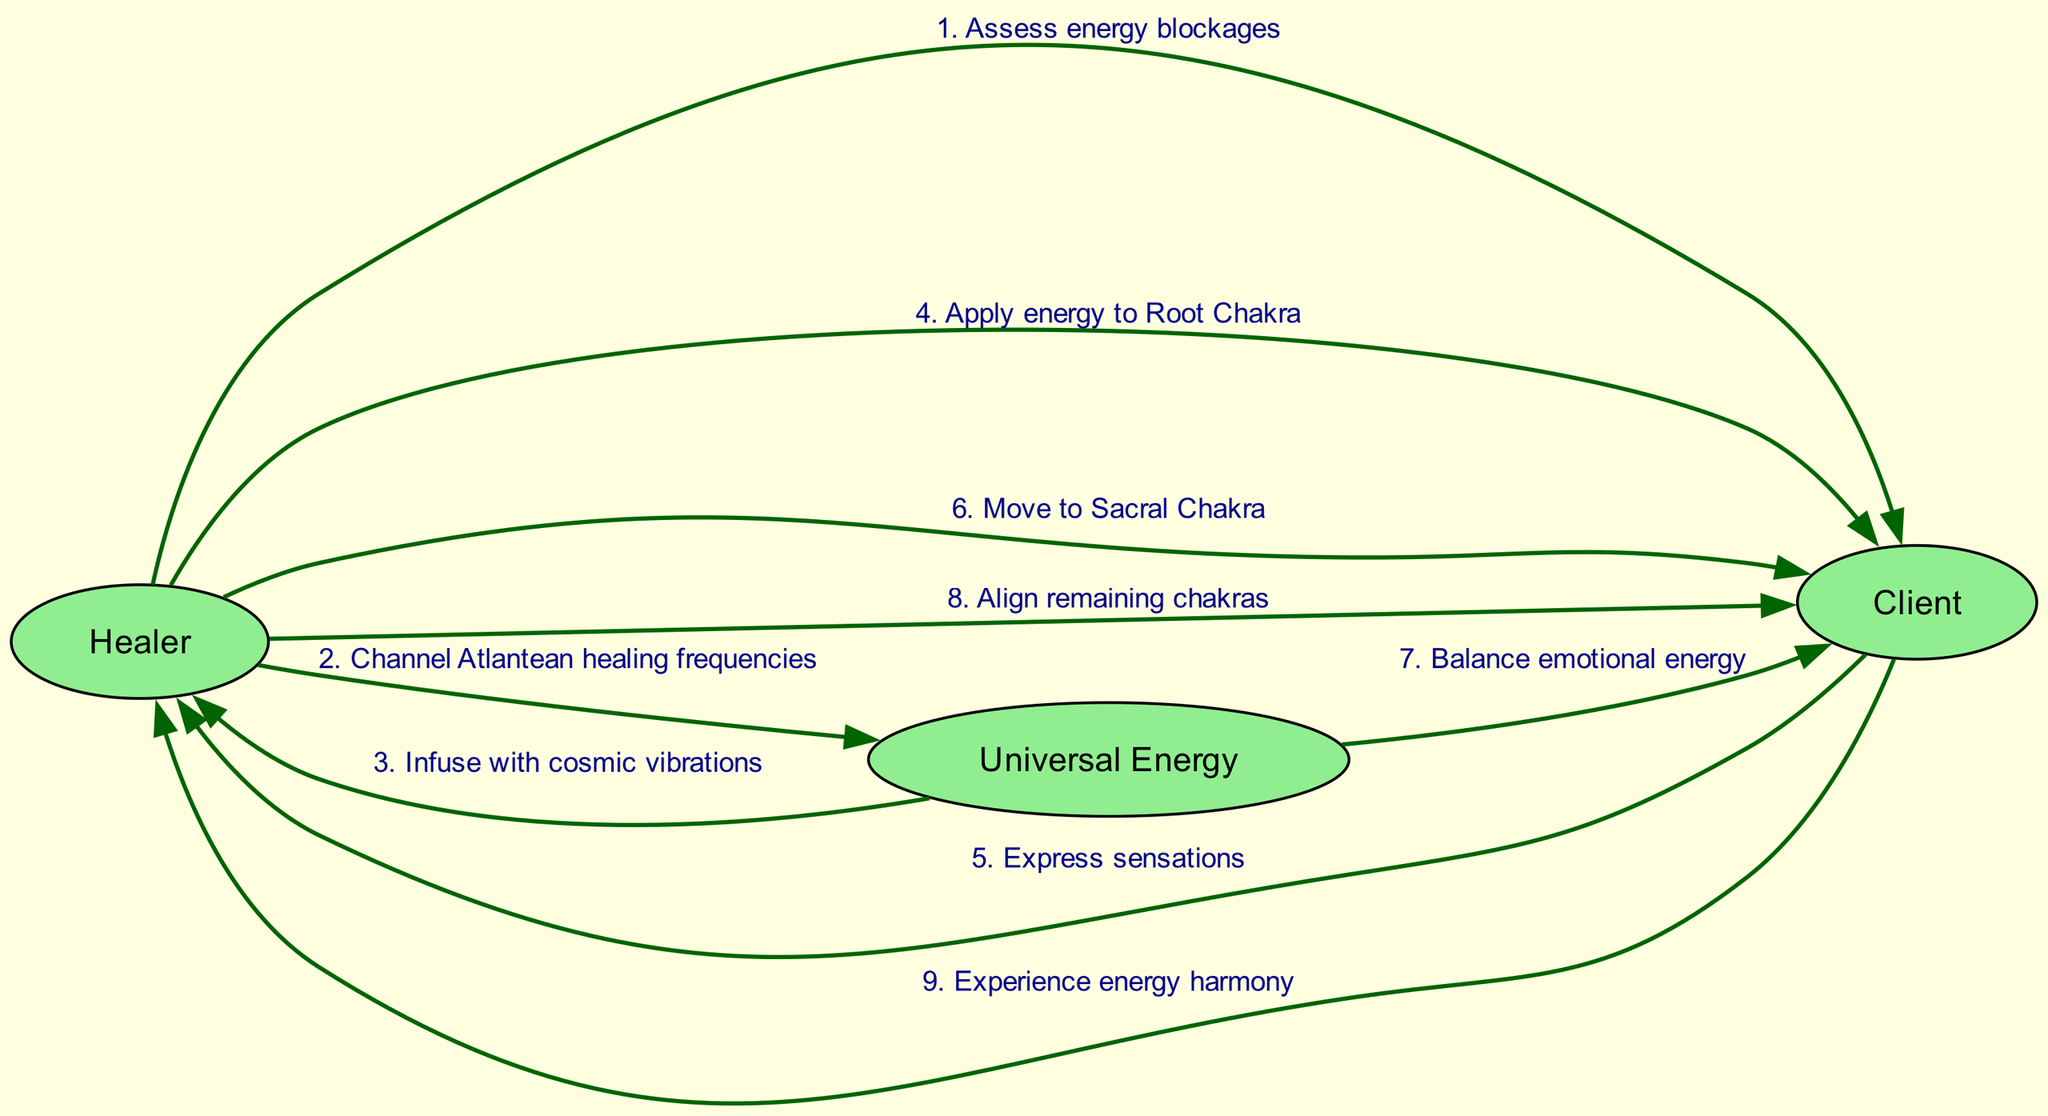What is the first action taken by the Healer? The first action in the sequence from Healer to Client is to "Assess energy blockages." This is the very first step in the chakra alignment session shown in the diagram.
Answer: Assess energy blockages How many actors are involved in the session? The diagram lists three actors: Healer, Client, and Universal Energy. Therefore, the total number of actors involved in the session is three.
Answer: 3 What action does the Client take after the Healer applies energy to the Root Chakra? After the Healer applies energy to the Root Chakra, the Client expresses sensations. This action follows directly as represented in the diagram's sequence.
Answer: Express sensations What is the last action performed in the sequence? The last action in the sequence involves the Client experiencing energy harmony. This is the final outcome of the entire process of energy work depicted in the diagram.
Answer: Experience energy harmony After the Healer channels Atlantean healing frequencies, what does the Universal Energy do next? After the Healer channels Atlantean healing frequencies, the Universal Energy infuses the Healer with cosmic vibrations. This step is crucial as it enables the Healer to work with the energies effectively.
Answer: Infuse with cosmic vibrations Which chakra is aligned after the Root Chakra and before the remaining chakras? The action indicates that after the Healer applies energy to the Root Chakra, the next step is to move to the Sacral Chakra. The diagram shows a clear sequence in chakra alignment.
Answer: Sacral Chakra What entity balances the emotional energy of the Client? The action of balancing emotional energy is performed by the Universal Energy, as indicated in the diagram. This reflects the spiritual aspect of energy alignment during the session.
Answer: Universal Energy Which actor communicates with the Healer after experiencing the Root Chakra energy? The Client is the one who communicates with the Healer after experiencing the sensations related to the Root Chakra energy. This interaction shows the flow of communication between participants.
Answer: Client 